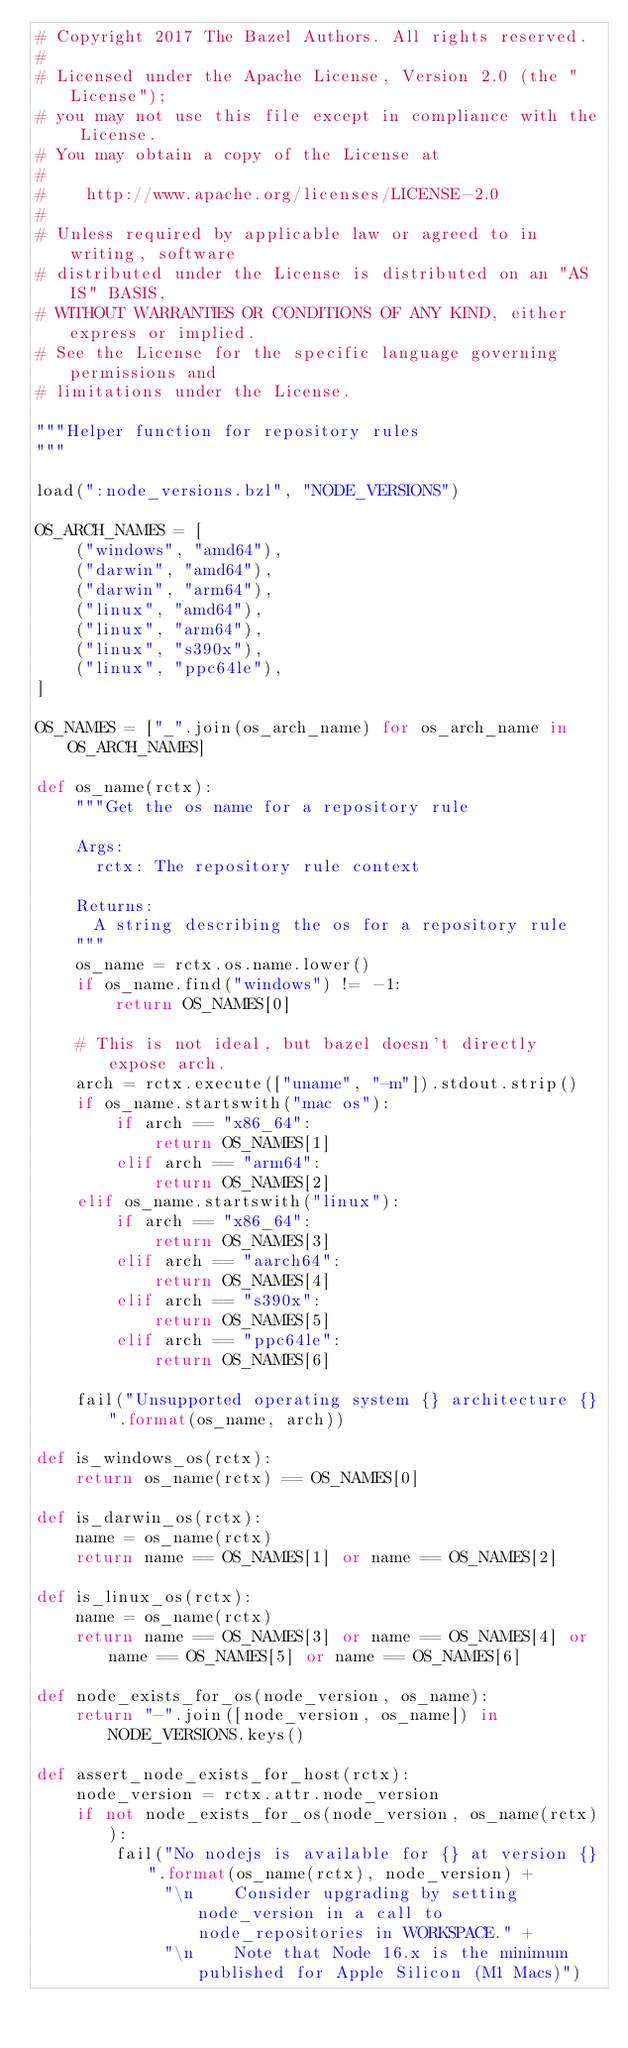<code> <loc_0><loc_0><loc_500><loc_500><_Python_># Copyright 2017 The Bazel Authors. All rights reserved.
#
# Licensed under the Apache License, Version 2.0 (the "License");
# you may not use this file except in compliance with the License.
# You may obtain a copy of the License at
#
#    http://www.apache.org/licenses/LICENSE-2.0
#
# Unless required by applicable law or agreed to in writing, software
# distributed under the License is distributed on an "AS IS" BASIS,
# WITHOUT WARRANTIES OR CONDITIONS OF ANY KIND, either express or implied.
# See the License for the specific language governing permissions and
# limitations under the License.

"""Helper function for repository rules
"""

load(":node_versions.bzl", "NODE_VERSIONS")

OS_ARCH_NAMES = [
    ("windows", "amd64"),
    ("darwin", "amd64"),
    ("darwin", "arm64"),
    ("linux", "amd64"),
    ("linux", "arm64"),
    ("linux", "s390x"),
    ("linux", "ppc64le"),
]

OS_NAMES = ["_".join(os_arch_name) for os_arch_name in OS_ARCH_NAMES]

def os_name(rctx):
    """Get the os name for a repository rule

    Args:
      rctx: The repository rule context

    Returns:
      A string describing the os for a repository rule
    """
    os_name = rctx.os.name.lower()
    if os_name.find("windows") != -1:
        return OS_NAMES[0]

    # This is not ideal, but bazel doesn't directly expose arch.
    arch = rctx.execute(["uname", "-m"]).stdout.strip()
    if os_name.startswith("mac os"):
        if arch == "x86_64":
            return OS_NAMES[1]
        elif arch == "arm64":
            return OS_NAMES[2]
    elif os_name.startswith("linux"):
        if arch == "x86_64":
            return OS_NAMES[3]
        elif arch == "aarch64":
            return OS_NAMES[4]
        elif arch == "s390x":
            return OS_NAMES[5]
        elif arch == "ppc64le":
            return OS_NAMES[6]

    fail("Unsupported operating system {} architecture {}".format(os_name, arch))

def is_windows_os(rctx):
    return os_name(rctx) == OS_NAMES[0]

def is_darwin_os(rctx):
    name = os_name(rctx)
    return name == OS_NAMES[1] or name == OS_NAMES[2]

def is_linux_os(rctx):
    name = os_name(rctx)
    return name == OS_NAMES[3] or name == OS_NAMES[4] or name == OS_NAMES[5] or name == OS_NAMES[6]

def node_exists_for_os(node_version, os_name):
    return "-".join([node_version, os_name]) in NODE_VERSIONS.keys()

def assert_node_exists_for_host(rctx):
    node_version = rctx.attr.node_version
    if not node_exists_for_os(node_version, os_name(rctx)):
        fail("No nodejs is available for {} at version {}".format(os_name(rctx), node_version) +
             "\n    Consider upgrading by setting node_version in a call to node_repositories in WORKSPACE." +
             "\n    Note that Node 16.x is the minimum published for Apple Silicon (M1 Macs)")
</code> 